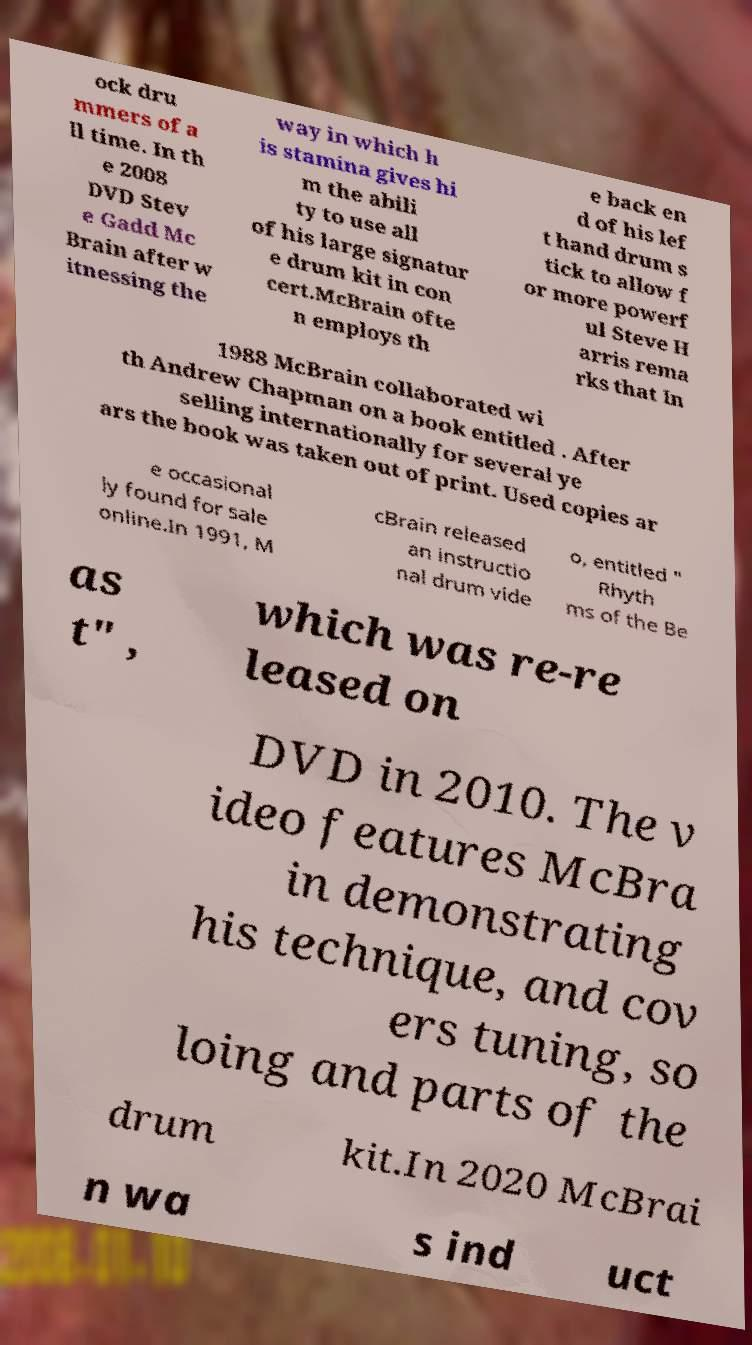Can you read and provide the text displayed in the image?This photo seems to have some interesting text. Can you extract and type it out for me? ock dru mmers of a ll time. In th e 2008 DVD Stev e Gadd Mc Brain after w itnessing the way in which h is stamina gives hi m the abili ty to use all of his large signatur e drum kit in con cert.McBrain ofte n employs th e back en d of his lef t hand drum s tick to allow f or more powerf ul Steve H arris rema rks that In 1988 McBrain collaborated wi th Andrew Chapman on a book entitled . After selling internationally for several ye ars the book was taken out of print. Used copies ar e occasional ly found for sale online.In 1991, M cBrain released an instructio nal drum vide o, entitled " Rhyth ms of the Be as t" , which was re-re leased on DVD in 2010. The v ideo features McBra in demonstrating his technique, and cov ers tuning, so loing and parts of the drum kit.In 2020 McBrai n wa s ind uct 